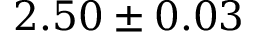<formula> <loc_0><loc_0><loc_500><loc_500>2 . 5 0 \pm 0 . 0 3</formula> 